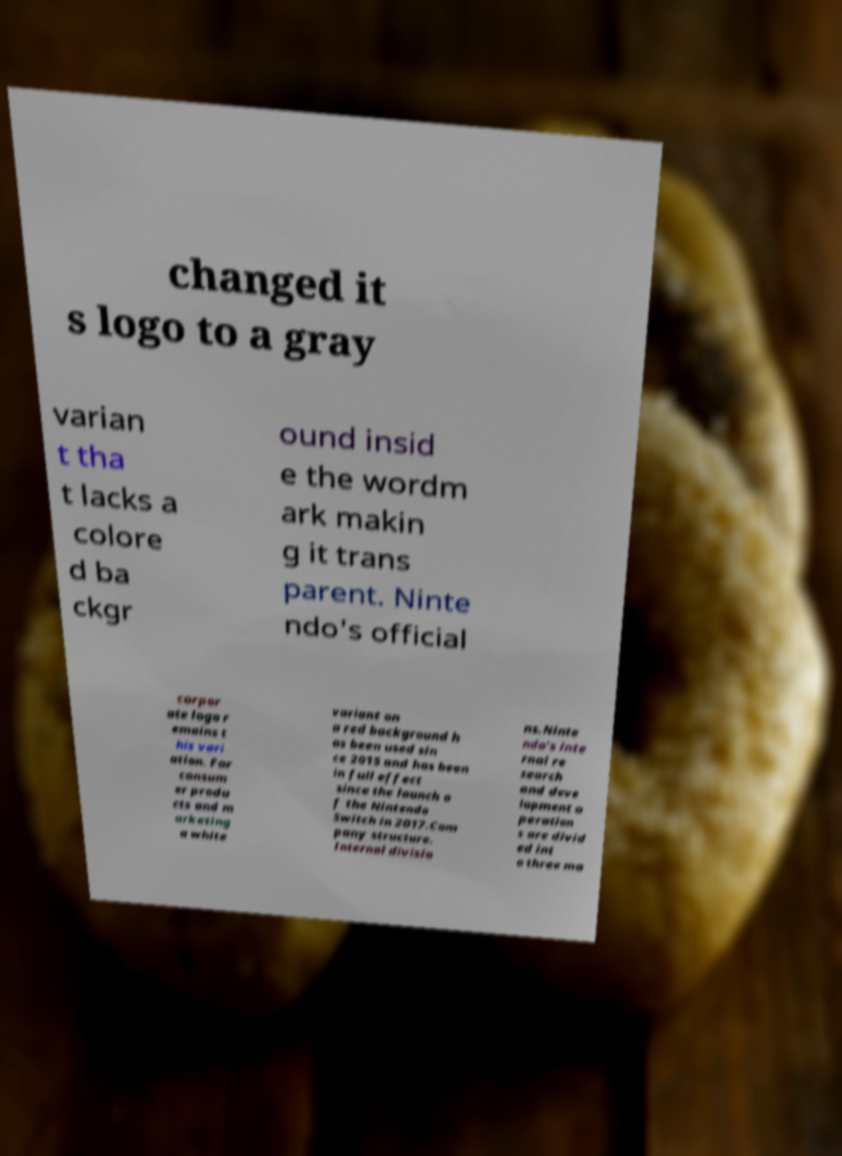Can you read and provide the text displayed in the image?This photo seems to have some interesting text. Can you extract and type it out for me? changed it s logo to a gray varian t tha t lacks a colore d ba ckgr ound insid e the wordm ark makin g it trans parent. Ninte ndo's official corpor ate logo r emains t his vari ation. For consum er produ cts and m arketing a white variant on a red background h as been used sin ce 2015 and has been in full effect since the launch o f the Nintendo Switch in 2017.Com pany structure. Internal divisio ns.Ninte ndo's inte rnal re search and deve lopment o peration s are divid ed int o three ma 